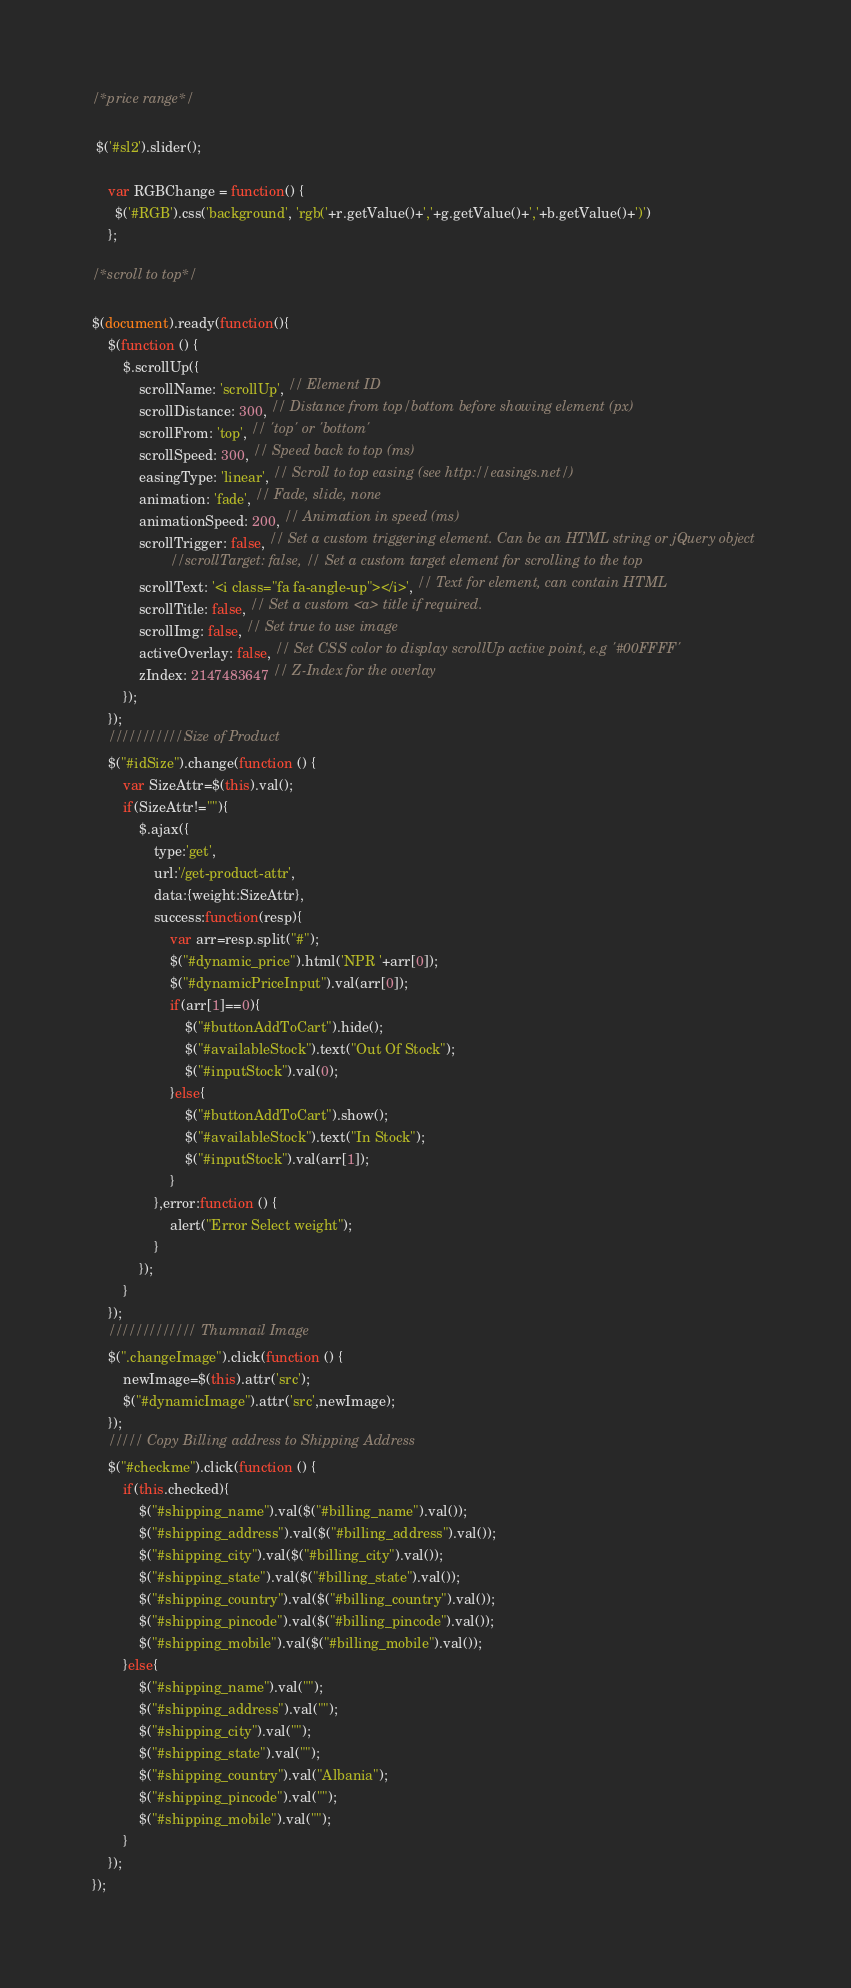Convert code to text. <code><loc_0><loc_0><loc_500><loc_500><_JavaScript_>/*price range*/

 $('#sl2').slider();

	var RGBChange = function() {
	  $('#RGB').css('background', 'rgb('+r.getValue()+','+g.getValue()+','+b.getValue()+')')
	};	
		
/*scroll to top*/

$(document).ready(function(){
	$(function () {
		$.scrollUp({
	        scrollName: 'scrollUp', // Element ID
	        scrollDistance: 300, // Distance from top/bottom before showing element (px)
	        scrollFrom: 'top', // 'top' or 'bottom'
	        scrollSpeed: 300, // Speed back to top (ms)
	        easingType: 'linear', // Scroll to top easing (see http://easings.net/)
	        animation: 'fade', // Fade, slide, none
	        animationSpeed: 200, // Animation in speed (ms)
	        scrollTrigger: false, // Set a custom triggering element. Can be an HTML string or jQuery object
					//scrollTarget: false, // Set a custom target element for scrolling to the top
	        scrollText: '<i class="fa fa-angle-up"></i>', // Text for element, can contain HTML
	        scrollTitle: false, // Set a custom <a> title if required.
	        scrollImg: false, // Set true to use image
	        activeOverlay: false, // Set CSS color to display scrollUp active point, e.g '#00FFFF'
	        zIndex: 2147483647 // Z-Index for the overlay
		});
	});
	///////////Size of Product
	$("#idSize").change(function () {
		var SizeAttr=$(this).val();
		if(SizeAttr!=""){
            $.ajax({
                type:'get',
                url:'/get-product-attr',
                data:{weight:SizeAttr},
                success:function(resp){
                	var arr=resp.split("#");
                    $("#dynamic_price").html('NPR '+arr[0]);
                    $("#dynamicPriceInput").val(arr[0]);
                    if(arr[1]==0){
						$("#buttonAddToCart").hide();
						$("#availableStock").text("Out Of Stock");
                        $("#inputStock").val(0);
					}else{
                        $("#buttonAddToCart").show();
                        $("#availableStock").text("In Stock");
                        $("#inputStock").val(arr[1]);
					}
                },error:function () {
                    alert("Error Select weight");
                }
            });
		}
    });
	///////////// Thumnail Image
	$(".changeImage").click(function () {
		newImage=$(this).attr('src');
		$("#dynamicImage").attr('src',newImage);
    });
	///// Copy Billing address to Shipping Address
	$("#checkme").click(function () {
		if(this.checked){
			$("#shipping_name").val($("#billing_name").val());
            $("#shipping_address").val($("#billing_address").val());
            $("#shipping_city").val($("#billing_city").val());
            $("#shipping_state").val($("#billing_state").val());
            $("#shipping_country").val($("#billing_country").val());
            $("#shipping_pincode").val($("#billing_pincode").val());
            $("#shipping_mobile").val($("#billing_mobile").val());
		}else{
            $("#shipping_name").val("");
            $("#shipping_address").val("");
            $("#shipping_city").val("");
            $("#shipping_state").val("");
            $("#shipping_country").val("Albania");
            $("#shipping_pincode").val("");
            $("#shipping_mobile").val("");
		}
    });
});
</code> 